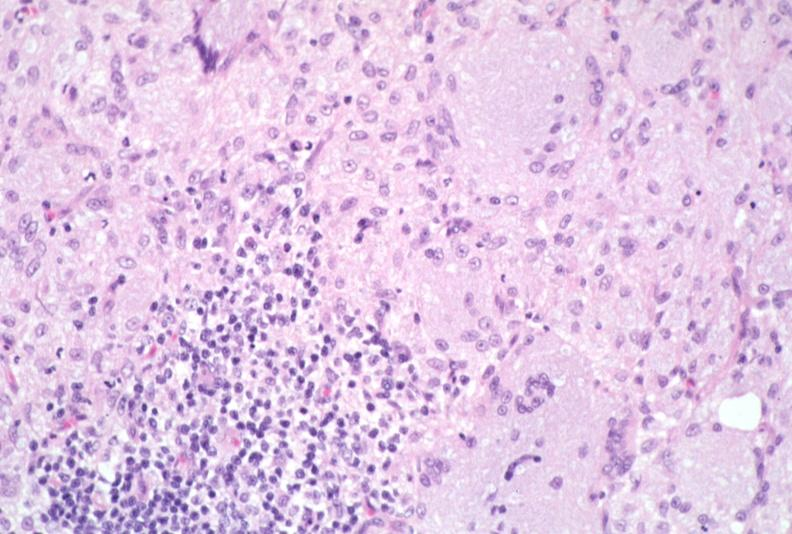what does this image show?
Answer the question using a single word or phrase. Lymph node 